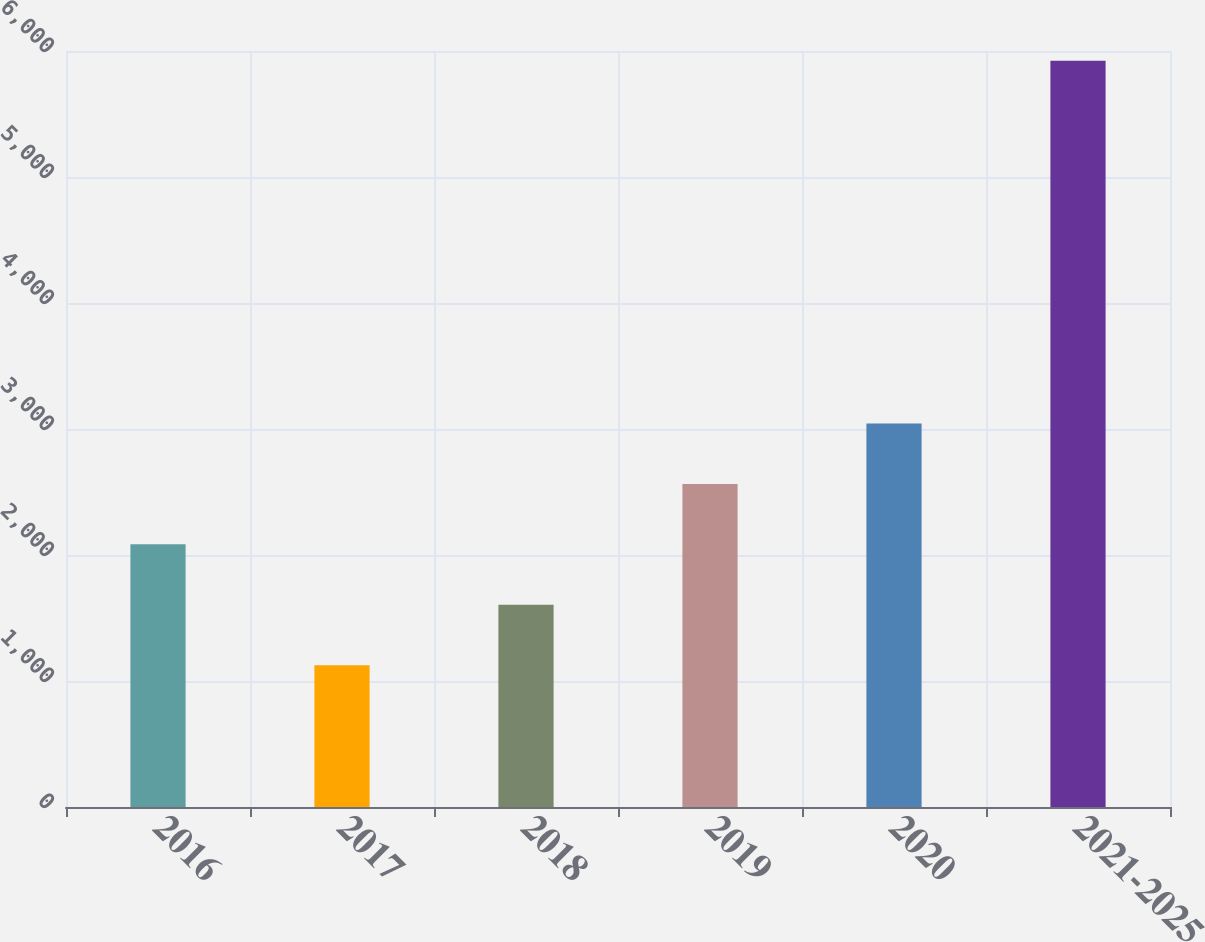<chart> <loc_0><loc_0><loc_500><loc_500><bar_chart><fcel>2016<fcel>2017<fcel>2018<fcel>2019<fcel>2020<fcel>2021-2025<nl><fcel>2084.4<fcel>1125<fcel>1604.7<fcel>2564.1<fcel>3043.8<fcel>5922<nl></chart> 